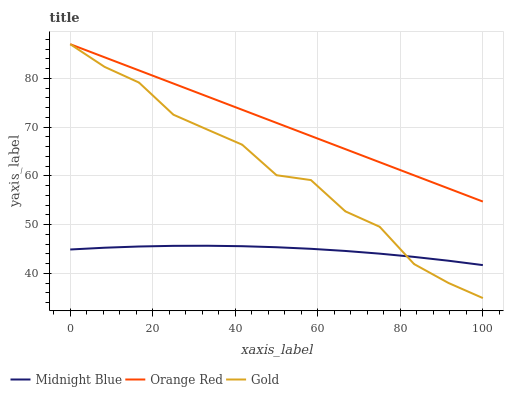Does Midnight Blue have the minimum area under the curve?
Answer yes or no. Yes. Does Orange Red have the maximum area under the curve?
Answer yes or no. Yes. Does Gold have the minimum area under the curve?
Answer yes or no. No. Does Gold have the maximum area under the curve?
Answer yes or no. No. Is Orange Red the smoothest?
Answer yes or no. Yes. Is Gold the roughest?
Answer yes or no. Yes. Is Gold the smoothest?
Answer yes or no. No. Is Orange Red the roughest?
Answer yes or no. No. Does Orange Red have the lowest value?
Answer yes or no. No. Does Orange Red have the highest value?
Answer yes or no. Yes. Is Midnight Blue less than Orange Red?
Answer yes or no. Yes. Is Orange Red greater than Midnight Blue?
Answer yes or no. Yes. Does Orange Red intersect Gold?
Answer yes or no. Yes. Is Orange Red less than Gold?
Answer yes or no. No. Is Orange Red greater than Gold?
Answer yes or no. No. Does Midnight Blue intersect Orange Red?
Answer yes or no. No. 